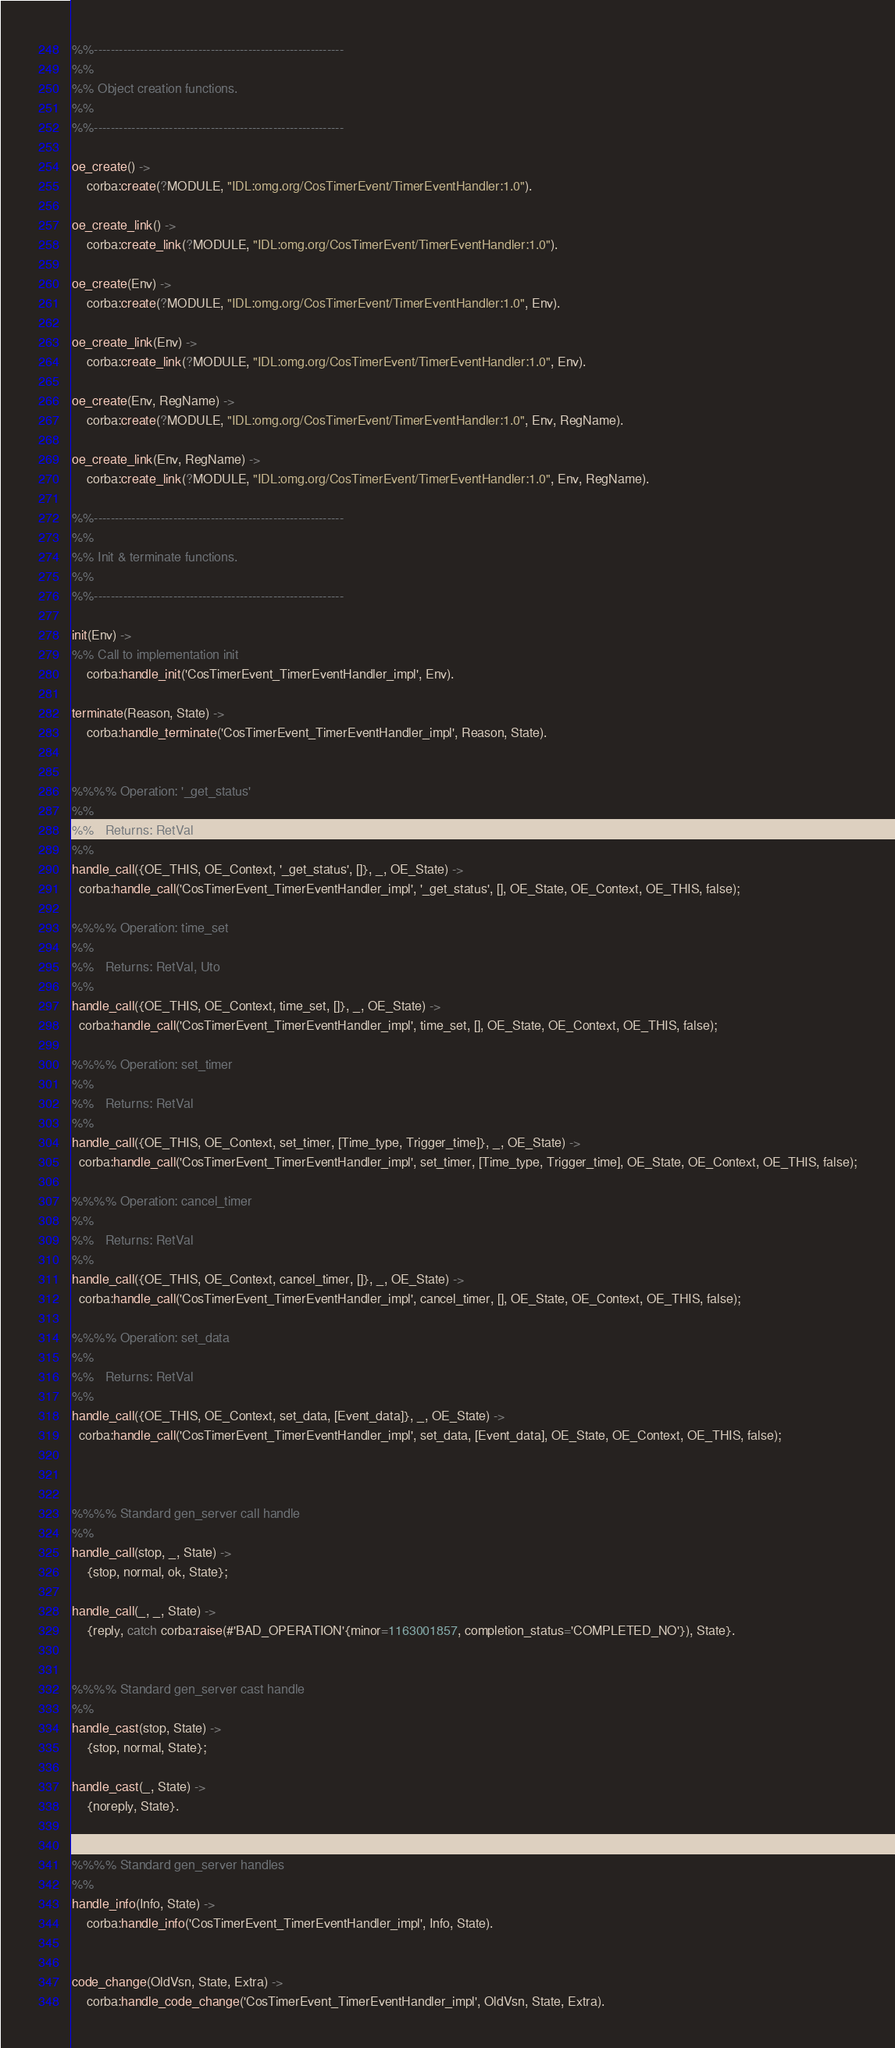Convert code to text. <code><loc_0><loc_0><loc_500><loc_500><_Erlang_>

%%------------------------------------------------------------
%%
%% Object creation functions.
%%
%%------------------------------------------------------------

oe_create() ->
    corba:create(?MODULE, "IDL:omg.org/CosTimerEvent/TimerEventHandler:1.0").

oe_create_link() ->
    corba:create_link(?MODULE, "IDL:omg.org/CosTimerEvent/TimerEventHandler:1.0").

oe_create(Env) ->
    corba:create(?MODULE, "IDL:omg.org/CosTimerEvent/TimerEventHandler:1.0", Env).

oe_create_link(Env) ->
    corba:create_link(?MODULE, "IDL:omg.org/CosTimerEvent/TimerEventHandler:1.0", Env).

oe_create(Env, RegName) ->
    corba:create(?MODULE, "IDL:omg.org/CosTimerEvent/TimerEventHandler:1.0", Env, RegName).

oe_create_link(Env, RegName) ->
    corba:create_link(?MODULE, "IDL:omg.org/CosTimerEvent/TimerEventHandler:1.0", Env, RegName).

%%------------------------------------------------------------
%%
%% Init & terminate functions.
%%
%%------------------------------------------------------------

init(Env) ->
%% Call to implementation init
    corba:handle_init('CosTimerEvent_TimerEventHandler_impl', Env).

terminate(Reason, State) ->
    corba:handle_terminate('CosTimerEvent_TimerEventHandler_impl', Reason, State).


%%%% Operation: '_get_status'
%% 
%%   Returns: RetVal
%%
handle_call({OE_THIS, OE_Context, '_get_status', []}, _, OE_State) ->
  corba:handle_call('CosTimerEvent_TimerEventHandler_impl', '_get_status', [], OE_State, OE_Context, OE_THIS, false);

%%%% Operation: time_set
%% 
%%   Returns: RetVal, Uto
%%
handle_call({OE_THIS, OE_Context, time_set, []}, _, OE_State) ->
  corba:handle_call('CosTimerEvent_TimerEventHandler_impl', time_set, [], OE_State, OE_Context, OE_THIS, false);

%%%% Operation: set_timer
%% 
%%   Returns: RetVal
%%
handle_call({OE_THIS, OE_Context, set_timer, [Time_type, Trigger_time]}, _, OE_State) ->
  corba:handle_call('CosTimerEvent_TimerEventHandler_impl', set_timer, [Time_type, Trigger_time], OE_State, OE_Context, OE_THIS, false);

%%%% Operation: cancel_timer
%% 
%%   Returns: RetVal
%%
handle_call({OE_THIS, OE_Context, cancel_timer, []}, _, OE_State) ->
  corba:handle_call('CosTimerEvent_TimerEventHandler_impl', cancel_timer, [], OE_State, OE_Context, OE_THIS, false);

%%%% Operation: set_data
%% 
%%   Returns: RetVal
%%
handle_call({OE_THIS, OE_Context, set_data, [Event_data]}, _, OE_State) ->
  corba:handle_call('CosTimerEvent_TimerEventHandler_impl', set_data, [Event_data], OE_State, OE_Context, OE_THIS, false);



%%%% Standard gen_server call handle
%%
handle_call(stop, _, State) ->
    {stop, normal, ok, State};

handle_call(_, _, State) ->
    {reply, catch corba:raise(#'BAD_OPERATION'{minor=1163001857, completion_status='COMPLETED_NO'}), State}.


%%%% Standard gen_server cast handle
%%
handle_cast(stop, State) ->
    {stop, normal, State};

handle_cast(_, State) ->
    {noreply, State}.


%%%% Standard gen_server handles
%%
handle_info(Info, State) ->
    corba:handle_info('CosTimerEvent_TimerEventHandler_impl', Info, State).


code_change(OldVsn, State, Extra) ->
    corba:handle_code_change('CosTimerEvent_TimerEventHandler_impl', OldVsn, State, Extra).

</code> 